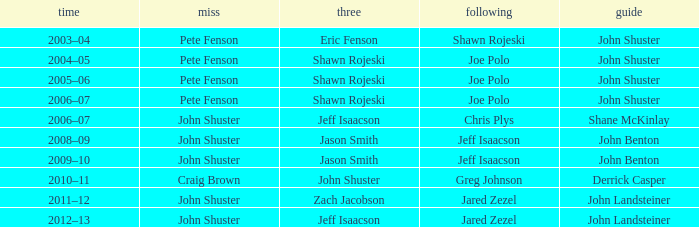Which season has Zach Jacobson in third? 2011–12. 